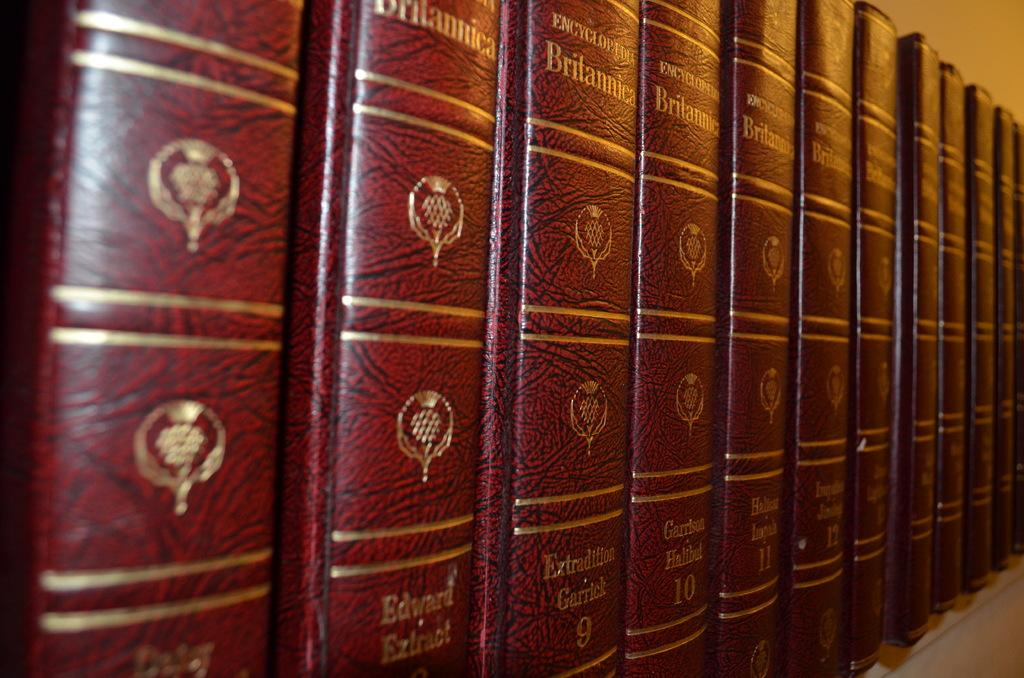<image>
Share a concise interpretation of the image provided. A encyclopedia book titled "Brilannica" by Edward Eztract. 